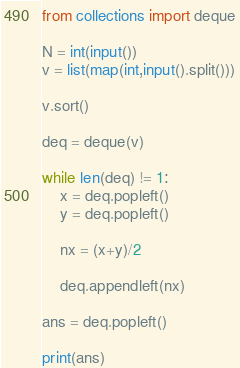<code> <loc_0><loc_0><loc_500><loc_500><_Python_>from collections import deque

N = int(input())
v = list(map(int,input().split()))

v.sort()

deq = deque(v)

while len(deq) != 1:
    x = deq.popleft()
    y = deq.popleft()
    
    nx = (x+y)/2
    
    deq.appendleft(nx)

ans = deq.popleft()

print(ans)</code> 